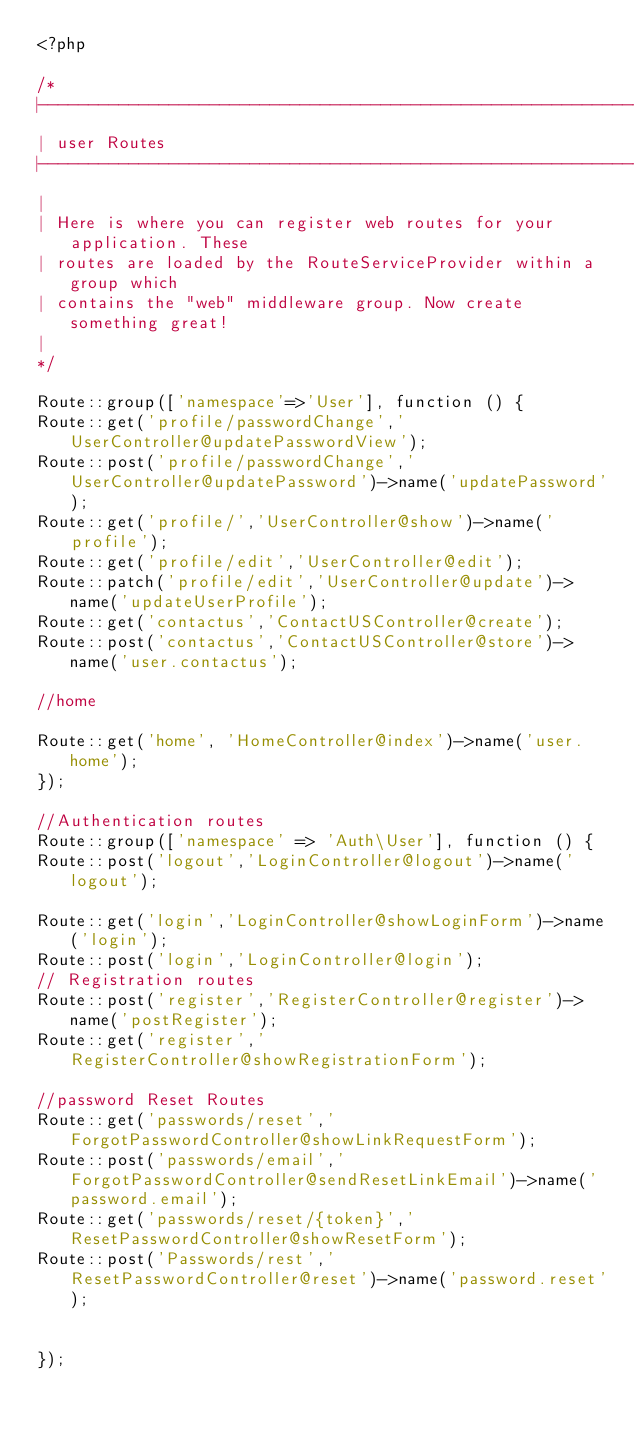<code> <loc_0><loc_0><loc_500><loc_500><_PHP_><?php

/*
|--------------------------------------------------------------------------
| user Routes
|--------------------------------------------------------------------------
|
| Here is where you can register web routes for your application. These
| routes are loaded by the RouteServiceProvider within a group which
| contains the "web" middleware group. Now create something great!
|
*/

Route::group(['namespace'=>'User'], function () {
Route::get('profile/passwordChange','UserController@updatePasswordView');
Route::post('profile/passwordChange','UserController@updatePassword')->name('updatePassword');
Route::get('profile/','UserController@show')->name('profile');
Route::get('profile/edit','UserController@edit');
Route::patch('profile/edit','UserController@update')->name('updateUserProfile');
Route::get('contactus','ContactUSController@create');
Route::post('contactus','ContactUSController@store')->name('user.contactus');

//home

Route::get('home', 'HomeController@index')->name('user.home');
});

//Authentication routes
Route::group(['namespace' => 'Auth\User'], function () {
Route::post('logout','LoginController@logout')->name('logout');

Route::get('login','LoginController@showLoginForm')->name('login');
Route::post('login','LoginController@login');
// Registration routes
Route::post('register','RegisterController@register')->name('postRegister');
Route::get('register','RegisterController@showRegistrationForm');

//password Reset Routes
Route::get('passwords/reset','ForgotPasswordController@showLinkRequestForm');
Route::post('passwords/email','ForgotPasswordController@sendResetLinkEmail')->name('password.email');
Route::get('passwords/reset/{token}','ResetPasswordController@showResetForm');
Route::post('Passwords/rest','ResetPasswordController@reset')->name('password.reset');


});</code> 